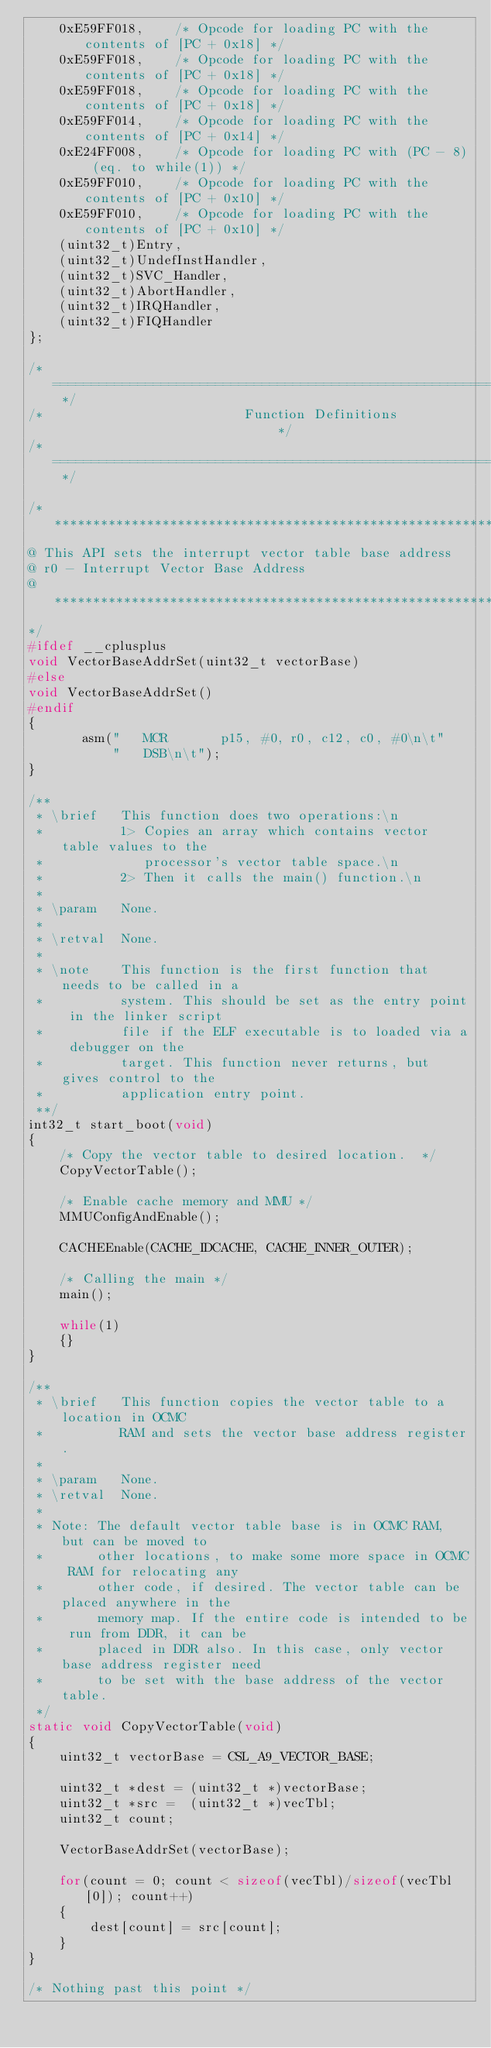<code> <loc_0><loc_0><loc_500><loc_500><_C_>    0xE59FF018,    /* Opcode for loading PC with the contents of [PC + 0x18] */
    0xE59FF018,    /* Opcode for loading PC with the contents of [PC + 0x18] */
    0xE59FF018,    /* Opcode for loading PC with the contents of [PC + 0x18] */
    0xE59FF014,    /* Opcode for loading PC with the contents of [PC + 0x14] */
    0xE24FF008,    /* Opcode for loading PC with (PC - 8) (eq. to while(1)) */
    0xE59FF010,    /* Opcode for loading PC with the contents of [PC + 0x10] */
    0xE59FF010,    /* Opcode for loading PC with the contents of [PC + 0x10] */
    (uint32_t)Entry,
    (uint32_t)UndefInstHandler,
    (uint32_t)SVC_Handler,
    (uint32_t)AbortHandler,
    (uint32_t)IRQHandler,
    (uint32_t)FIQHandler
};

/* ========================================================================== */
/*                          Function Definitions                              */
/* ========================================================================== */

/******************************************************************************
@ This API sets the interrupt vector table base address 
@ r0 - Interrupt Vector Base Address
@******************************************************************************
*/
#ifdef __cplusplus
void VectorBaseAddrSet(uint32_t vectorBase)
#else
void VectorBaseAddrSet()
#endif
{
       asm("   MCR       p15, #0, r0, c12, c0, #0\n\t"
           "   DSB\n\t");
}

/**
 * \brief   This function does two operations:\n
 *          1> Copies an array which contains vector table values to the
 *             processor's vector table space.\n
 *          2> Then it calls the main() function.\n
 *
 * \param   None.
 *
 * \retval  None.
 *
 * \note    This function is the first function that needs to be called in a
 *          system. This should be set as the entry point in the linker script
 *          file if the ELF executable is to loaded via a debugger on the
 *          target. This function never returns, but gives control to the
 *          application entry point.
 **/
int32_t start_boot(void)
{
    /* Copy the vector table to desired location.  */
    CopyVectorTable();

    /* Enable cache memory and MMU */
    MMUConfigAndEnable();

    CACHEEnable(CACHE_IDCACHE, CACHE_INNER_OUTER);

    /* Calling the main */
    main();

    while(1)
    {}
}

/**
 * \brief   This function copies the vector table to a location in OCMC
 *          RAM and sets the vector base address register.
 *
 * \param   None.
 * \retval  None.
 *
 * Note: The default vector table base is in OCMC RAM, but can be moved to
 *       other locations, to make some more space in OCMC RAM for relocating any
 *       other code, if desired. The vector table can be placed anywhere in the
 *       memory map. If the entire code is intended to be run from DDR, it can be
 *       placed in DDR also. In this case, only vector base address register need
 *       to be set with the base address of the vector table.
 */
static void CopyVectorTable(void)
{
    uint32_t vectorBase = CSL_A9_VECTOR_BASE;

    uint32_t *dest = (uint32_t *)vectorBase;
    uint32_t *src =  (uint32_t *)vecTbl;
    uint32_t count;

    VectorBaseAddrSet(vectorBase);

    for(count = 0; count < sizeof(vecTbl)/sizeof(vecTbl[0]); count++)
    {
        dest[count] = src[count];
    }
}

/* Nothing past this point */
</code> 